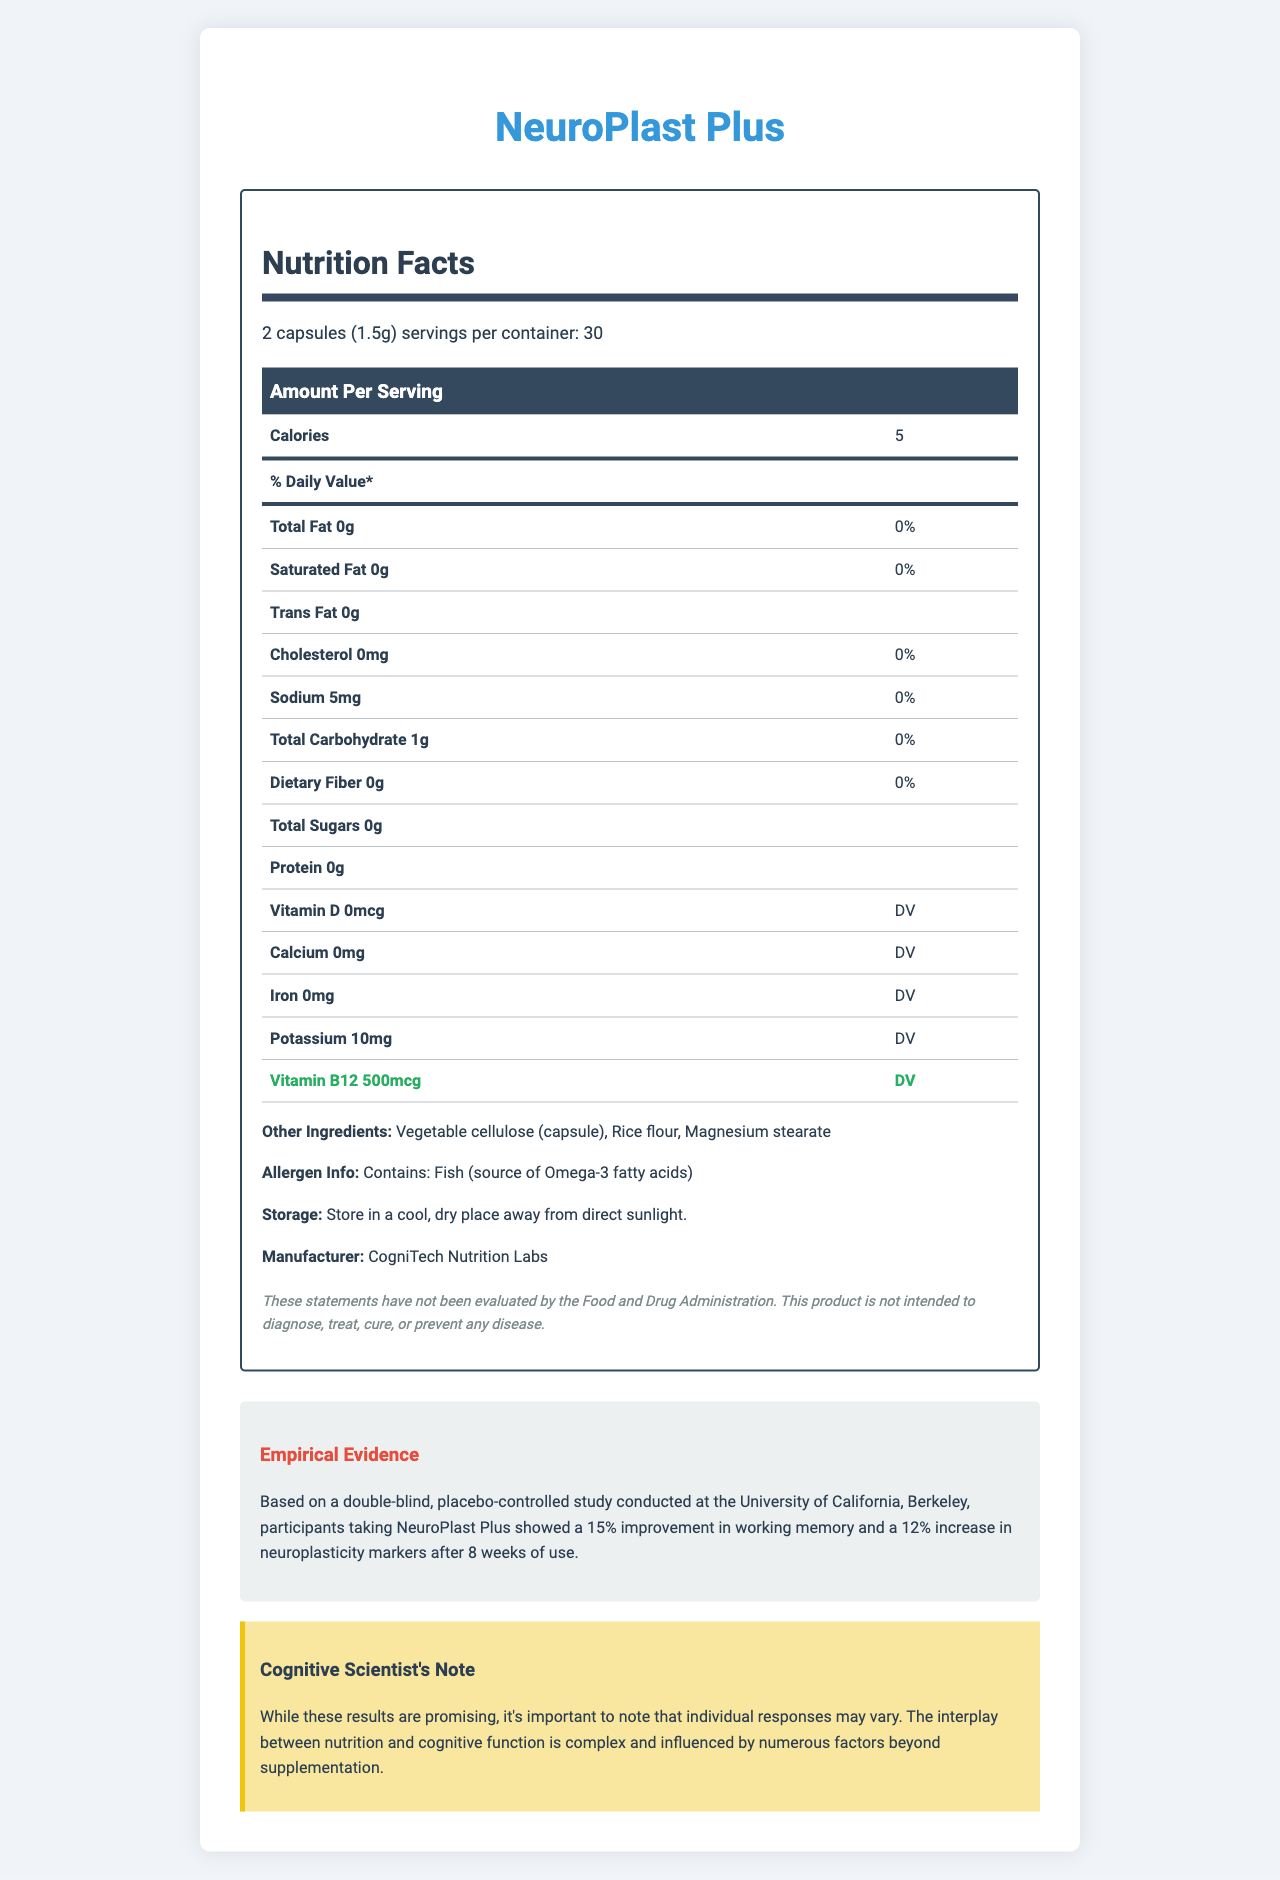what is the serving size? The serving size is given on the nutrition label as "2 capsules (1.5g)".
Answer: 2 capsules (1.5g) how many calories are there per serving? The number of calories per serving is specified as 5 in the nutrition label.
Answer: 5 how much sodium is in each serving? According to the nutrition label, each serving contains 5mg of sodium.
Answer: 5mg how much vitamin B12 is there per serving, in terms of % Daily Value? The nutrition label states that each serving contains 500mcg of Vitamin B12, which is 20833% of the Daily Value (DV).
Answer: 20833% is there any cholesterol in the product? The nutrition label indicates that the cholesterol content is 0mg.
Answer: No which of the following ingredients is not listed in "Other Ingredients"? A. Vegetable cellulose B. Magnesium stearate C. Fish oil D. Rice flour The listed "Other Ingredients" include Vegetable cellulose, Magnesium stearate, and Rice flour, but not Fish oil.
Answer: C. Fish oil what is the main beneficial ingredient related to neuroplasticity in this product? A. Vitamin D B. Bacopa Monnieri Extract C. Sodium D. Calcium Bacopa Monnieri Extract is known to aid in cognitive performance and neuroplasticity, which aligns with the product's advertised function.
Answer: B. Bacopa Monnieri Extract is this product intended to diagnose, treat, cure, or prevent any disease? The disclaimer explicitly states that the product is not intended to diagnose, treat, cure, or prevent any disease.
Answer: No summarize the main features of NeuroPlast Plus. The primary information about NeuroPlast Plus covers its nutritional content, major ingredients related to cognitive enhancement, empirical evidence of efficacy, and manufacturer details.
Answer: NeuroPlast Plus is a functional food product marketed to increase neuroplasticity and cognitive performance. It has a serving size of 2 capsules (1.5g) with 30 servings per container. It contains 5 calories per serving and major ingredients include Vitamin B12, Omega-3 fatty acids, Phosphatidylserine, Bacopa Monnieri Extract, Lion's Mane Mushroom Extract, Alpha GPC, L-Theanine, and Ginkgo Biloba Extract. It has no fat, cholesterol, or sugar and provides a significant amount of Vitamin B12 (20833% DV). The product also contains vegetable cellulose, rice flour, and magnesium stearate and is manufactured by CogniTech Nutrition Labs. Empirical evidence from a study shows improvements in working memory and neuroplasticity. what is the primary empirical evidence supporting the efficacy of NeuroPlast Plus? The document states the empirical evidence from a specific study showing improvements in working memory and neuroplasticity markers among participants after 8 weeks.
Answer: Participants taking NeuroPlast Plus showed a 15% improvement in working memory and a 12% increase in neuroplasticity markers after 8 weeks of use based on a double-blind, placebo-controlled study conducted at the University of California, Berkeley. how should NeuroPlast Plus be stored? The storage instructions are provided in the document stating that the product should be kept in a cool, dry place away from direct sunlight.
Answer: Store in a cool, dry place away from direct sunlight. can we determine if this product is suitable for people with fish allergies? The allergen information mentions that the product contains fish (a source of Omega-3 fatty acids), indicating it may not be suitable for people with fish allergies.
Answer: No 